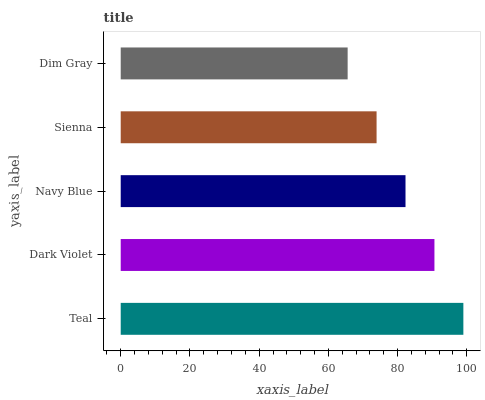Is Dim Gray the minimum?
Answer yes or no. Yes. Is Teal the maximum?
Answer yes or no. Yes. Is Dark Violet the minimum?
Answer yes or no. No. Is Dark Violet the maximum?
Answer yes or no. No. Is Teal greater than Dark Violet?
Answer yes or no. Yes. Is Dark Violet less than Teal?
Answer yes or no. Yes. Is Dark Violet greater than Teal?
Answer yes or no. No. Is Teal less than Dark Violet?
Answer yes or no. No. Is Navy Blue the high median?
Answer yes or no. Yes. Is Navy Blue the low median?
Answer yes or no. Yes. Is Dark Violet the high median?
Answer yes or no. No. Is Dim Gray the low median?
Answer yes or no. No. 